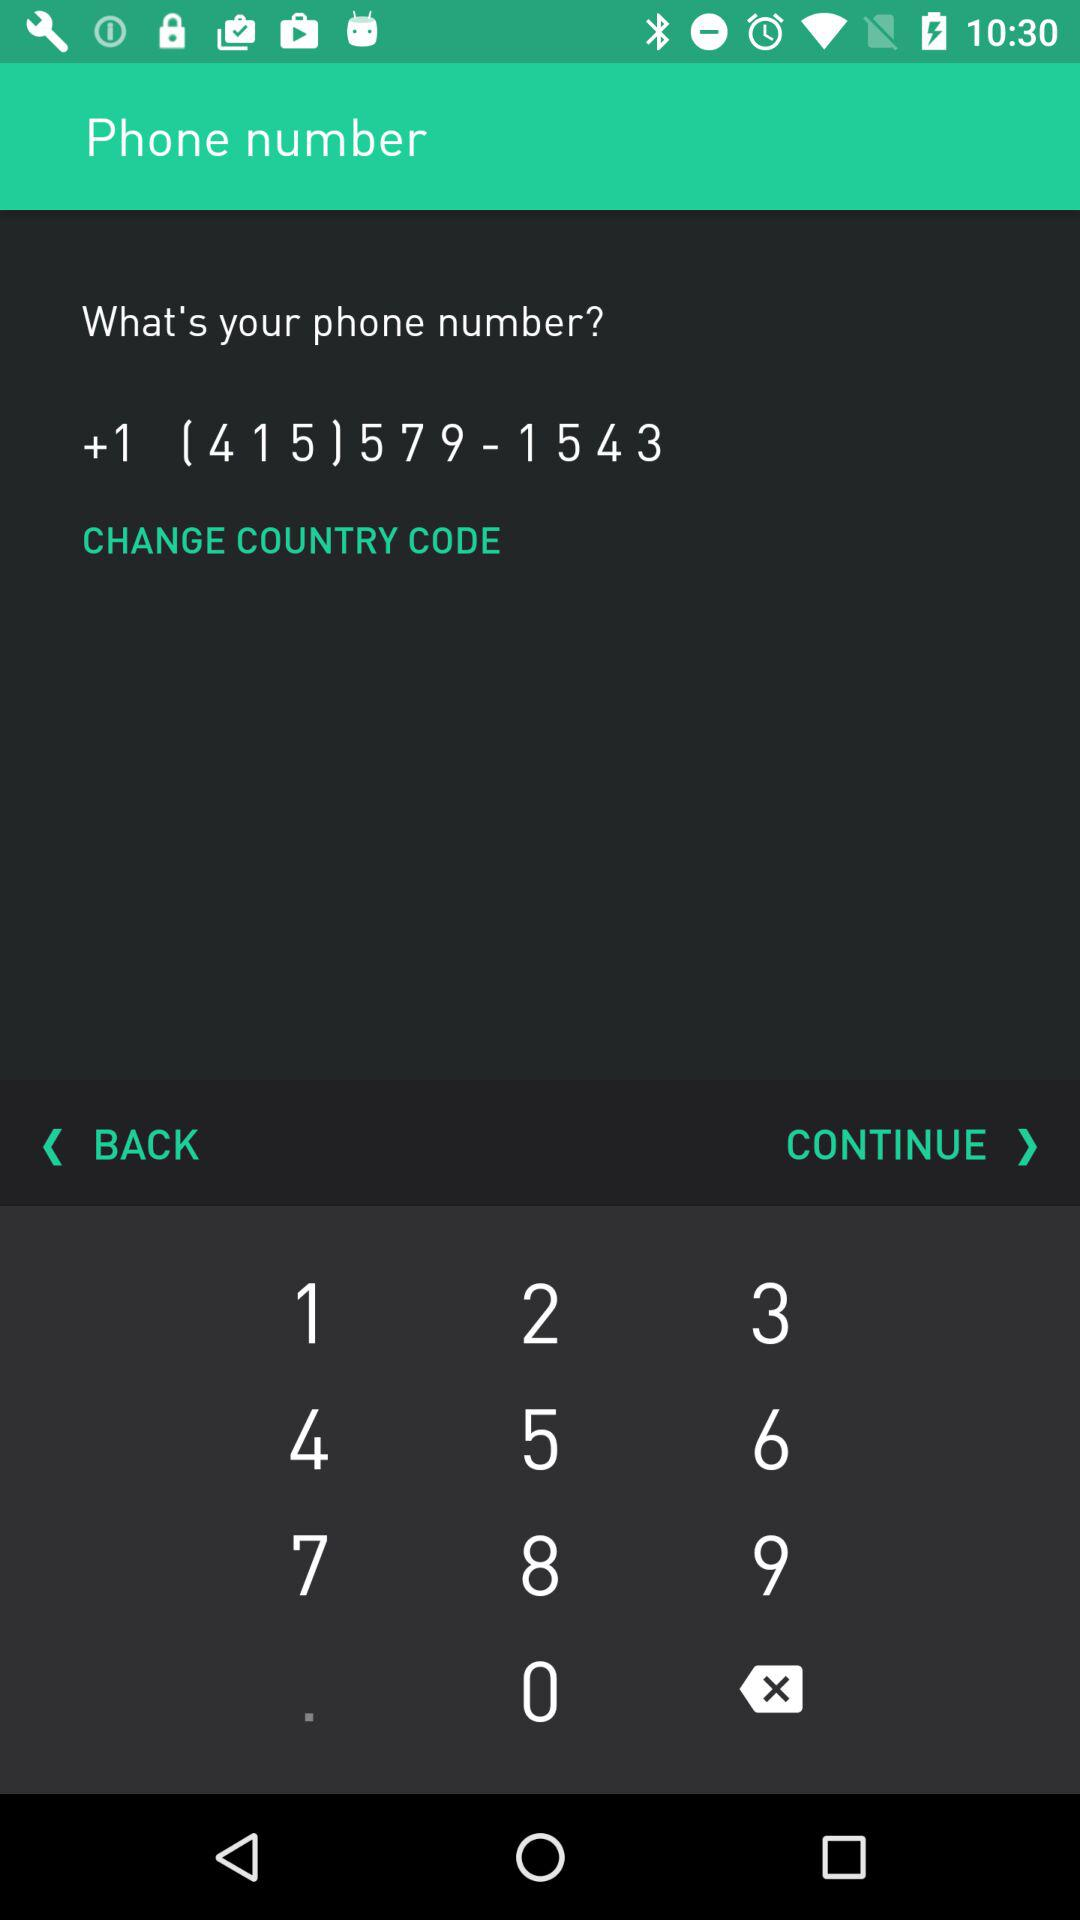What is the phone number? The phone number is +1 (415) 579-1543. 